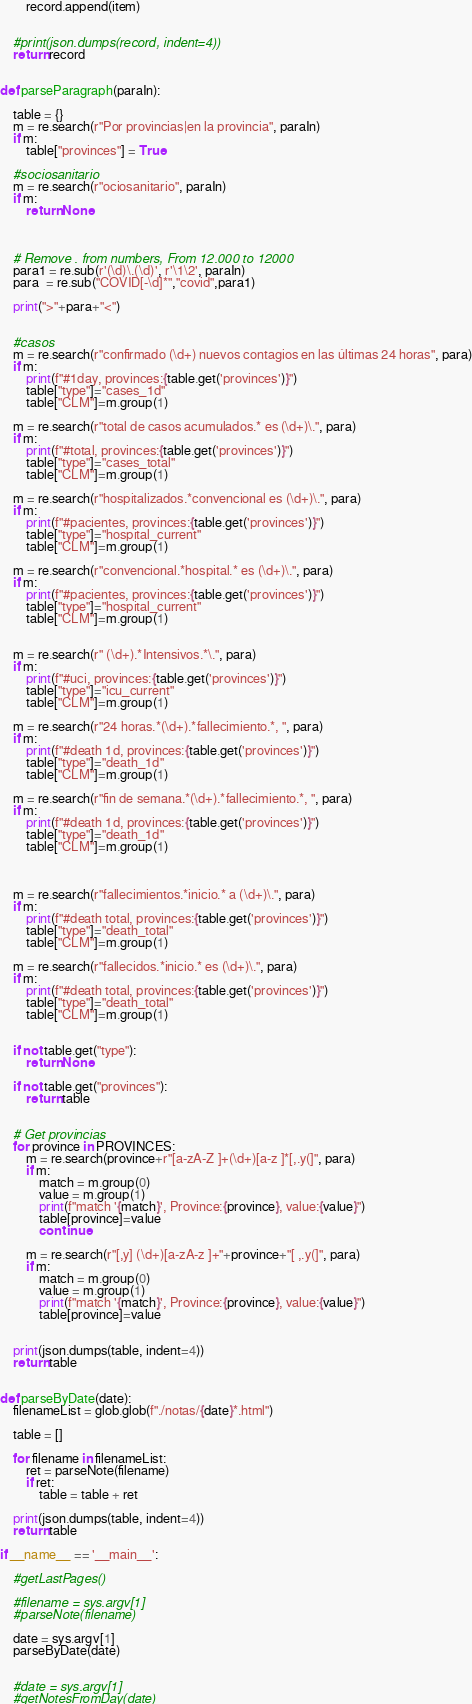Convert code to text. <code><loc_0><loc_0><loc_500><loc_500><_Python_>        record.append(item)


    #print(json.dumps(record, indent=4))
    return record


def parseParagraph(paraIn):

    table = {}
    m = re.search(r"Por provincias|en la provincia", paraIn)
    if m:
        table["provinces"] = True

    #sociosanitario
    m = re.search(r"ociosanitario", paraIn)
    if m:
        return None



    # Remove . from numbers, From 12.000 to 12000
    para1 = re.sub(r'(\d)\.(\d)', r'\1\2', paraIn)
    para  = re.sub("COVID[-\d]*","covid",para1)

    print(">"+para+"<")


    #casos
    m = re.search(r"confirmado (\d+) nuevos contagios en las últimas 24 horas", para)
    if m:
        print(f"#1day, provinces:{table.get('provinces')}")
        table["type"]="cases_1d"
        table["CLM"]=m.group(1)

    m = re.search(r"total de casos acumulados.* es (\d+)\.", para)
    if m:
        print(f"#total, provinces:{table.get('provinces')}")
        table["type"]="cases_total"
        table["CLM"]=m.group(1)

    m = re.search(r"hospitalizados.*convencional es (\d+)\.", para)
    if m:
        print(f"#pacientes, provinces:{table.get('provinces')}")
        table["type"]="hospital_current"
        table["CLM"]=m.group(1)

    m = re.search(r"convencional.*hospital.* es (\d+)\.", para)
    if m:
        print(f"#pacientes, provinces:{table.get('provinces')}")
        table["type"]="hospital_current"
        table["CLM"]=m.group(1)


    m = re.search(r" (\d+).*Intensivos.*\.", para)
    if m:
        print(f"#uci, provinces:{table.get('provinces')}")
        table["type"]="icu_current"
        table["CLM"]=m.group(1)

    m = re.search(r"24 horas.*(\d+).*fallecimiento.*, ", para)
    if m:
        print(f"#death 1d, provinces:{table.get('provinces')}")
        table["type"]="death_1d"
        table["CLM"]=m.group(1)

    m = re.search(r"fin de semana.*(\d+).*fallecimiento.*, ", para)
    if m:
        print(f"#death 1d, provinces:{table.get('provinces')}")
        table["type"]="death_1d"
        table["CLM"]=m.group(1)



    m = re.search(r"fallecimientos.*inicio.* a (\d+)\.", para)
    if m:
        print(f"#death total, provinces:{table.get('provinces')}")
        table["type"]="death_total"
        table["CLM"]=m.group(1)

    m = re.search(r"fallecidos.*inicio.* es (\d+)\.", para)
    if m:
        print(f"#death total, provinces:{table.get('provinces')}")
        table["type"]="death_total"
        table["CLM"]=m.group(1)


    if not table.get("type"):
        return None

    if not table.get("provinces"):
        return table


    # Get provincias
    for province in PROVINCES:
        m = re.search(province+r"[a-zA-Z ]+(\d+)[a-z ]*[,.y(]", para)
        if m:
            match = m.group(0)
            value = m.group(1)
            print(f"match '{match}', Province:{province}, value:{value}")
            table[province]=value
            continue

        m = re.search(r"[,y] (\d+)[a-zA-z ]+"+province+"[ ,.y(]", para)
        if m:
            match = m.group(0)
            value = m.group(1)
            print(f"match '{match}', Province:{province}, value:{value}")
            table[province]=value            
        

    print(json.dumps(table, indent=4))
    return table


def parseByDate(date):
    filenameList = glob.glob(f"./notas/{date}*.html")

    table = []

    for filename in filenameList:
        ret = parseNote(filename) 
        if ret:
            table = table + ret

    print(json.dumps(table, indent=4))
    return table

if __name__ == '__main__':

    #getLastPages()

    #filename = sys.argv[1]
    #parseNote(filename)

    date = sys.argv[1]
    parseByDate(date)


    #date = sys.argv[1]
    #getNotesFromDay(date)
</code> 